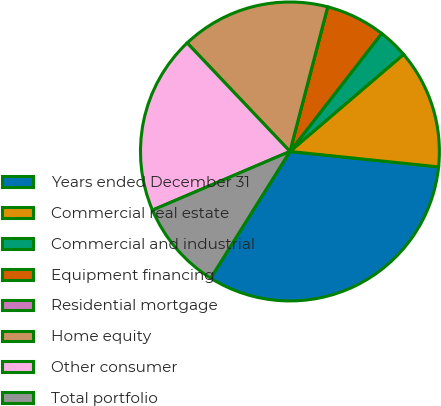<chart> <loc_0><loc_0><loc_500><loc_500><pie_chart><fcel>Years ended December 31<fcel>Commercial real estate<fcel>Commercial and industrial<fcel>Equipment financing<fcel>Residential mortgage<fcel>Home equity<fcel>Other consumer<fcel>Total portfolio<nl><fcel>32.25%<fcel>12.9%<fcel>3.23%<fcel>6.45%<fcel>0.0%<fcel>16.13%<fcel>19.35%<fcel>9.68%<nl></chart> 